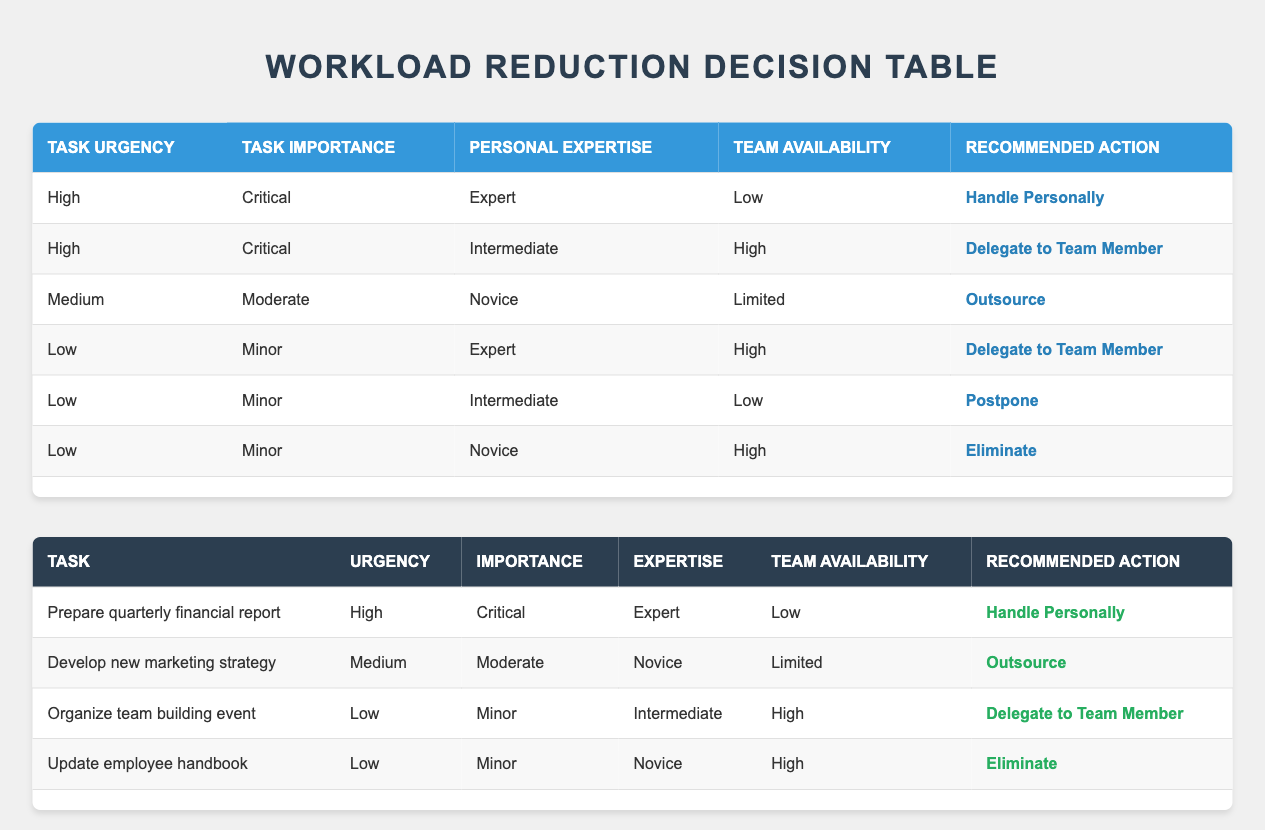What is the recommended action for a task that is high urgency, critical importance, and you have intermediate expertise with high team availability? According to the rules, for a task with high urgency, critical importance, intermediate expertise, and high team availability, the recommended action is "Delegate to Team Member" as per the second rule in the decision table.
Answer: Delegate to Team Member For a task deemed low urgency and minor importance, what are the possible actions if you are a novice and your team availability is high? The rules indicate that if a task is low urgency, minor importance, you are a novice, and team availability is high, the recommended action is "Eliminate" as stated in the last rule of the table.
Answer: Eliminate What is the total number of actions listed in the decision table? There are five actions listed in the table: Handle Personally, Delegate to Team Member, Outsource, Postpone, and Eliminate. Summing them gives a total of 5 actions.
Answer: 5 Is it true that a task categorized as medium urgency and moderate importance should always be outsourced? This is false; a task categorized as medium urgency and moderate importance with novice expertise and limited team availability should be outsourced, but this does not apply if the urgency or importance changes. There are cases with different conditions where the actions can vary.
Answer: No What recommended action would you take for a task with low urgency, minor importance, expert expertise, and high team availability? According to the decision table rules, the action would be to "Delegate to Team Member" since the conditions match the corresponding rule.
Answer: Delegate to Team Member How many total tasks in the examples require handling personally? The only task in the examples requiring handling personally is "Prepare quarterly financial report." Therefore, the total is 1.
Answer: 1 If a task is high urgency and critical importance, what is the likely expert level for an appropriate action to handle it if team availability is low? The table shows that high urgency and critical importance in the context of low team availability would recommend handling it personally only if the expertise is expert, meaning expertise is critical to the action being suggested.
Answer: Expert Which task is suggested for outsourcing? The task "Develop new marketing strategy" is suggested for outsourcing, as it fits the condition of medium urgency, moderate importance, novice expertise, and limited team availability.
Answer: Develop new marketing strategy 